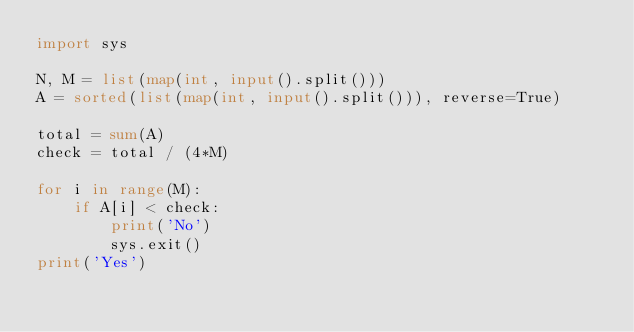Convert code to text. <code><loc_0><loc_0><loc_500><loc_500><_Python_>import sys

N, M = list(map(int, input().split()))
A = sorted(list(map(int, input().split())), reverse=True)

total = sum(A)
check = total / (4*M)

for i in range(M):
    if A[i] < check:
        print('No')
        sys.exit()
print('Yes')</code> 